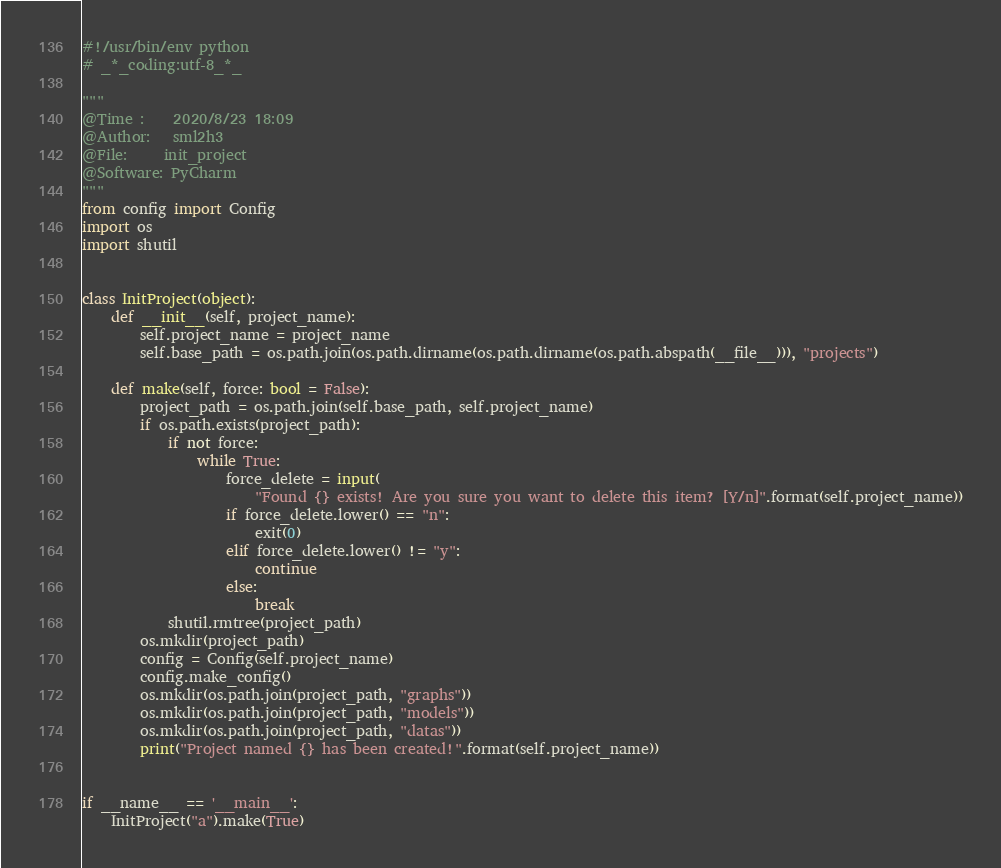<code> <loc_0><loc_0><loc_500><loc_500><_Python_>#!/usr/bin/env python
# _*_coding:utf-8_*_

"""
@Time :    2020/8/23 18:09
@Author:   sml2h3
@File:     init_project
@Software: PyCharm
"""
from config import Config
import os
import shutil


class InitProject(object):
    def __init__(self, project_name):
        self.project_name = project_name
        self.base_path = os.path.join(os.path.dirname(os.path.dirname(os.path.abspath(__file__))), "projects")

    def make(self, force: bool = False):
        project_path = os.path.join(self.base_path, self.project_name)
        if os.path.exists(project_path):
            if not force:
                while True:
                    force_delete = input(
                        "Found {} exists! Are you sure you want to delete this item? [Y/n]".format(self.project_name))
                    if force_delete.lower() == "n":
                        exit(0)
                    elif force_delete.lower() != "y":
                        continue
                    else:
                        break
            shutil.rmtree(project_path)
        os.mkdir(project_path)
        config = Config(self.project_name)
        config.make_config()
        os.mkdir(os.path.join(project_path, "graphs"))
        os.mkdir(os.path.join(project_path, "models"))
        os.mkdir(os.path.join(project_path, "datas"))
        print("Project named {} has been created!".format(self.project_name))


if __name__ == '__main__':
    InitProject("a").make(True)
</code> 